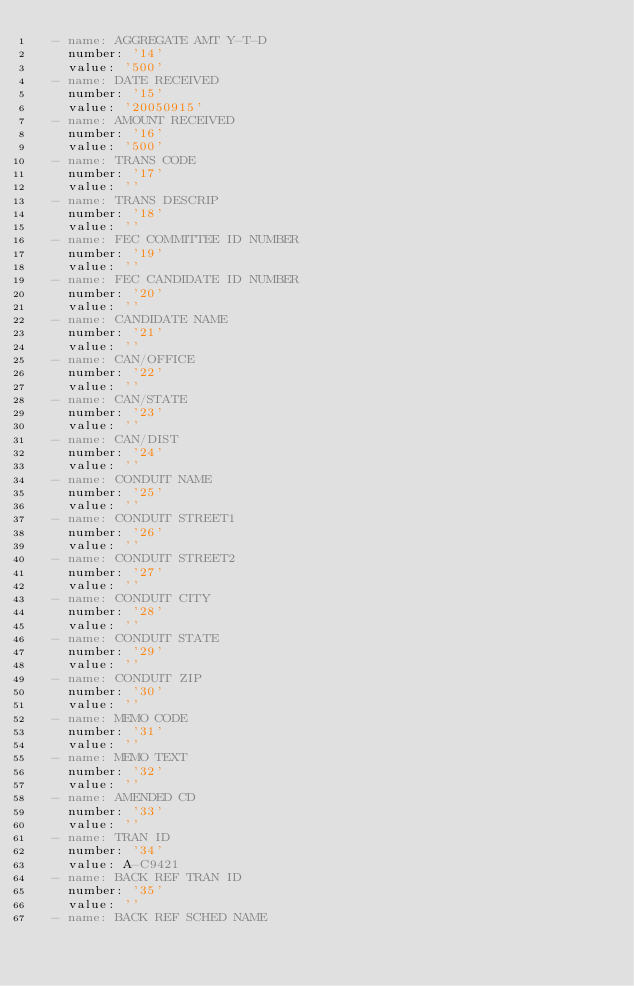Convert code to text. <code><loc_0><loc_0><loc_500><loc_500><_YAML_>  - name: AGGREGATE AMT Y-T-D
    number: '14'
    value: '500'
  - name: DATE RECEIVED
    number: '15'
    value: '20050915'
  - name: AMOUNT RECEIVED
    number: '16'
    value: '500'
  - name: TRANS CODE
    number: '17'
    value: ''
  - name: TRANS DESCRIP
    number: '18'
    value: ''
  - name: FEC COMMITTEE ID NUMBER
    number: '19'
    value: ''
  - name: FEC CANDIDATE ID NUMBER
    number: '20'
    value: ''
  - name: CANDIDATE NAME
    number: '21'
    value: ''
  - name: CAN/OFFICE
    number: '22'
    value: ''
  - name: CAN/STATE
    number: '23'
    value: ''
  - name: CAN/DIST
    number: '24'
    value: ''
  - name: CONDUIT NAME
    number: '25'
    value: ''
  - name: CONDUIT STREET1
    number: '26'
    value: ''
  - name: CONDUIT STREET2
    number: '27'
    value: ''
  - name: CONDUIT CITY
    number: '28'
    value: ''
  - name: CONDUIT STATE
    number: '29'
    value: ''
  - name: CONDUIT ZIP
    number: '30'
    value: ''
  - name: MEMO CODE
    number: '31'
    value: ''
  - name: MEMO TEXT
    number: '32'
    value: ''
  - name: AMENDED CD
    number: '33'
    value: ''
  - name: TRAN ID
    number: '34'
    value: A-C9421
  - name: BACK REF TRAN ID
    number: '35'
    value: ''
  - name: BACK REF SCHED NAME</code> 